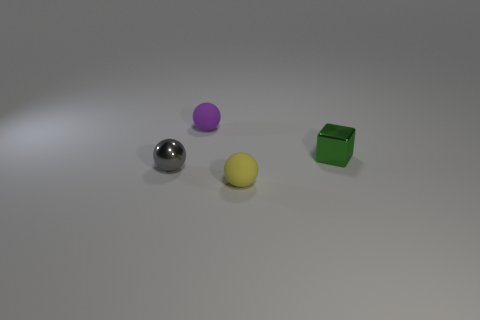What is the tiny thing that is on the right side of the yellow matte sphere made of?
Your answer should be very brief. Metal. Are there an equal number of tiny gray balls that are on the right side of the gray ball and green rubber cubes?
Your response must be concise. Yes. Does the gray metallic object have the same shape as the tiny purple object?
Offer a very short reply. Yes. There is a tiny object that is both behind the gray metallic thing and on the left side of the green cube; what shape is it?
Keep it short and to the point. Sphere. Are there an equal number of purple matte objects left of the green metallic object and small purple spheres behind the purple ball?
Offer a very short reply. No. How many balls are yellow things or tiny gray shiny objects?
Your answer should be compact. 2. What number of small yellow spheres have the same material as the purple object?
Your answer should be compact. 1. What material is the small object that is in front of the tiny purple object and behind the small shiny ball?
Your answer should be compact. Metal. There is a matte thing that is on the right side of the tiny purple matte thing; what is its shape?
Offer a terse response. Sphere. What shape is the small green thing that is on the right side of the small gray ball that is in front of the cube?
Keep it short and to the point. Cube. 